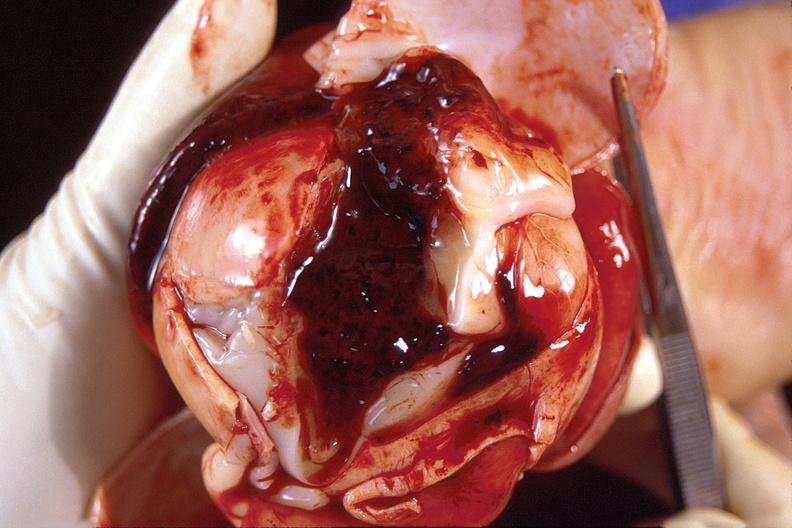does this image show brain, intraventricular hemorrhage?
Answer the question using a single word or phrase. Yes 